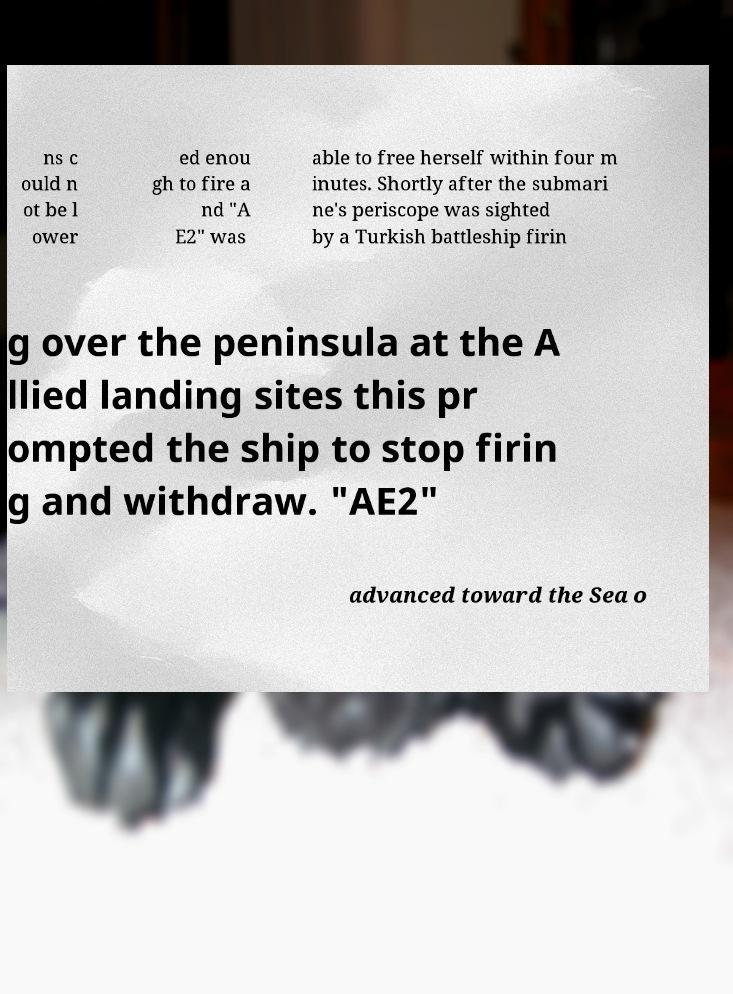Please read and relay the text visible in this image. What does it say? ns c ould n ot be l ower ed enou gh to fire a nd "A E2" was able to free herself within four m inutes. Shortly after the submari ne's periscope was sighted by a Turkish battleship firin g over the peninsula at the A llied landing sites this pr ompted the ship to stop firin g and withdraw. "AE2" advanced toward the Sea o 